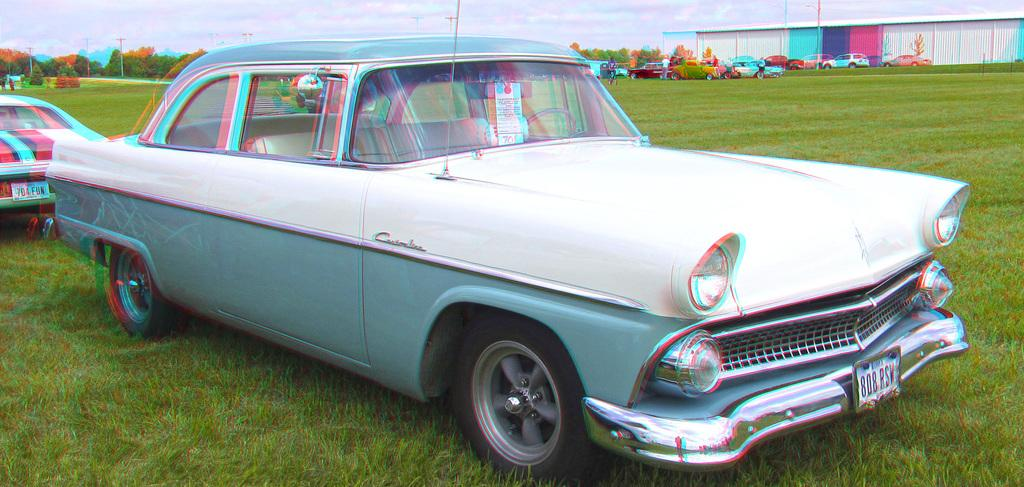What is located on the grass in the image? There is a car on the grass in the image. What structure can be seen on the right side of the image? There is an iron sheet shed on the right side of the image. What is visible at the top of the image? The sky is visible at the top of the image. Where is the scarecrow located in the image? There is no scarecrow present in the image. What type of tooth can be seen in the image? There are no teeth present in the image. 